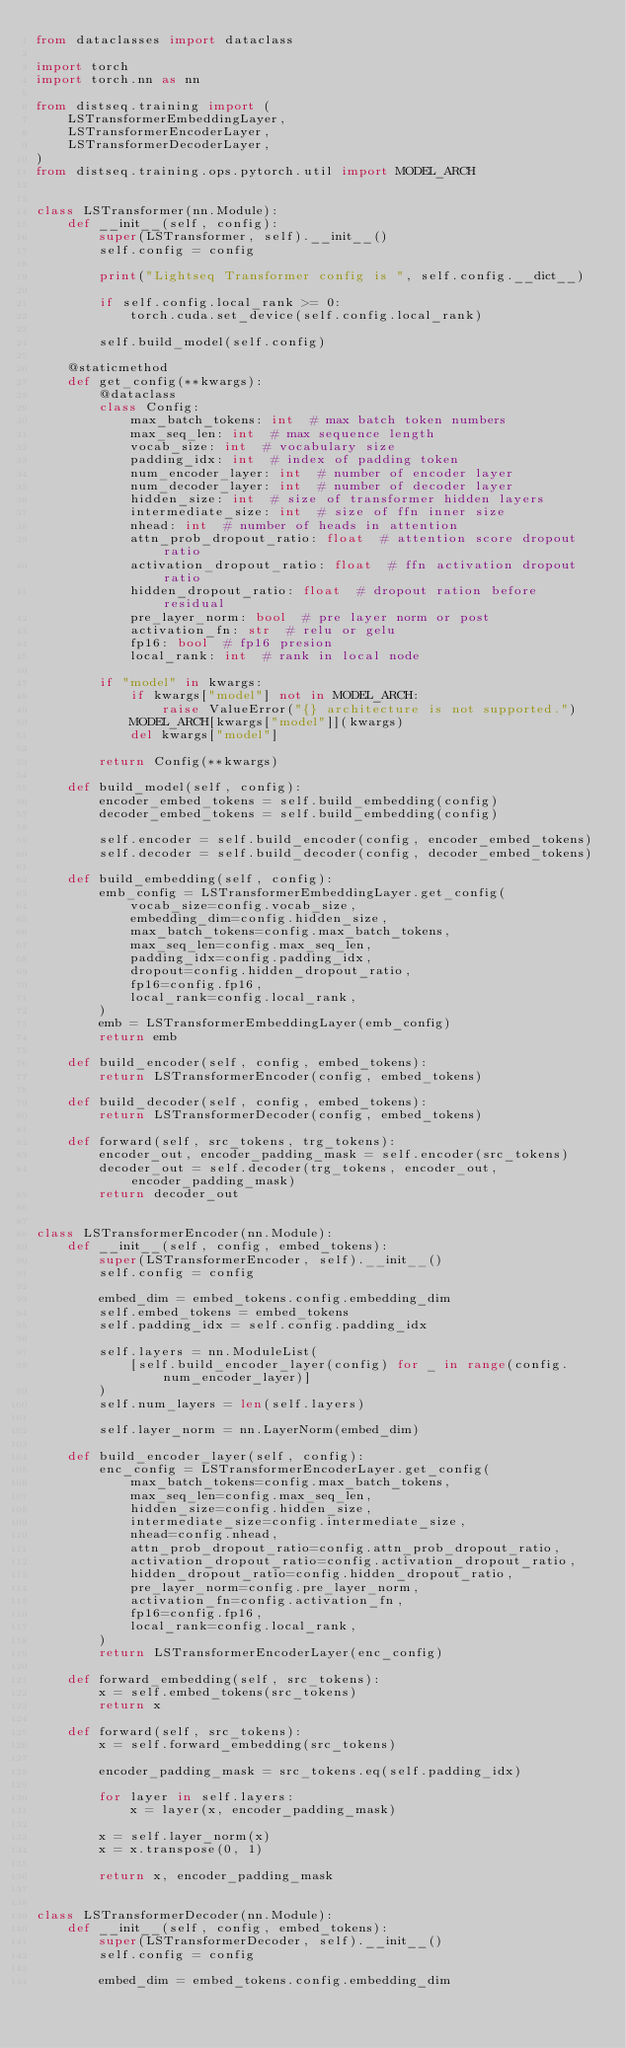<code> <loc_0><loc_0><loc_500><loc_500><_Python_>from dataclasses import dataclass

import torch
import torch.nn as nn

from distseq.training import (
    LSTransformerEmbeddingLayer,
    LSTransformerEncoderLayer,
    LSTransformerDecoderLayer,
)
from distseq.training.ops.pytorch.util import MODEL_ARCH


class LSTransformer(nn.Module):
    def __init__(self, config):
        super(LSTransformer, self).__init__()
        self.config = config

        print("Lightseq Transformer config is ", self.config.__dict__)

        if self.config.local_rank >= 0:
            torch.cuda.set_device(self.config.local_rank)

        self.build_model(self.config)

    @staticmethod
    def get_config(**kwargs):
        @dataclass
        class Config:
            max_batch_tokens: int  # max batch token numbers
            max_seq_len: int  # max sequence length
            vocab_size: int  # vocabulary size
            padding_idx: int  # index of padding token
            num_encoder_layer: int  # number of encoder layer
            num_decoder_layer: int  # number of decoder layer
            hidden_size: int  # size of transformer hidden layers
            intermediate_size: int  # size of ffn inner size
            nhead: int  # number of heads in attention
            attn_prob_dropout_ratio: float  # attention score dropout ratio
            activation_dropout_ratio: float  # ffn activation dropout ratio
            hidden_dropout_ratio: float  # dropout ration before residual
            pre_layer_norm: bool  # pre layer norm or post
            activation_fn: str  # relu or gelu
            fp16: bool  # fp16 presion
            local_rank: int  # rank in local node

        if "model" in kwargs:
            if kwargs["model"] not in MODEL_ARCH:
                raise ValueError("{} architecture is not supported.")
            MODEL_ARCH[kwargs["model"]](kwargs)
            del kwargs["model"]

        return Config(**kwargs)

    def build_model(self, config):
        encoder_embed_tokens = self.build_embedding(config)
        decoder_embed_tokens = self.build_embedding(config)

        self.encoder = self.build_encoder(config, encoder_embed_tokens)
        self.decoder = self.build_decoder(config, decoder_embed_tokens)

    def build_embedding(self, config):
        emb_config = LSTransformerEmbeddingLayer.get_config(
            vocab_size=config.vocab_size,
            embedding_dim=config.hidden_size,
            max_batch_tokens=config.max_batch_tokens,
            max_seq_len=config.max_seq_len,
            padding_idx=config.padding_idx,
            dropout=config.hidden_dropout_ratio,
            fp16=config.fp16,
            local_rank=config.local_rank,
        )
        emb = LSTransformerEmbeddingLayer(emb_config)
        return emb

    def build_encoder(self, config, embed_tokens):
        return LSTransformerEncoder(config, embed_tokens)

    def build_decoder(self, config, embed_tokens):
        return LSTransformerDecoder(config, embed_tokens)

    def forward(self, src_tokens, trg_tokens):
        encoder_out, encoder_padding_mask = self.encoder(src_tokens)
        decoder_out = self.decoder(trg_tokens, encoder_out, encoder_padding_mask)
        return decoder_out


class LSTransformerEncoder(nn.Module):
    def __init__(self, config, embed_tokens):
        super(LSTransformerEncoder, self).__init__()
        self.config = config

        embed_dim = embed_tokens.config.embedding_dim
        self.embed_tokens = embed_tokens
        self.padding_idx = self.config.padding_idx

        self.layers = nn.ModuleList(
            [self.build_encoder_layer(config) for _ in range(config.num_encoder_layer)]
        )
        self.num_layers = len(self.layers)

        self.layer_norm = nn.LayerNorm(embed_dim)

    def build_encoder_layer(self, config):
        enc_config = LSTransformerEncoderLayer.get_config(
            max_batch_tokens=config.max_batch_tokens,
            max_seq_len=config.max_seq_len,
            hidden_size=config.hidden_size,
            intermediate_size=config.intermediate_size,
            nhead=config.nhead,
            attn_prob_dropout_ratio=config.attn_prob_dropout_ratio,
            activation_dropout_ratio=config.activation_dropout_ratio,
            hidden_dropout_ratio=config.hidden_dropout_ratio,
            pre_layer_norm=config.pre_layer_norm,
            activation_fn=config.activation_fn,
            fp16=config.fp16,
            local_rank=config.local_rank,
        )
        return LSTransformerEncoderLayer(enc_config)

    def forward_embedding(self, src_tokens):
        x = self.embed_tokens(src_tokens)
        return x

    def forward(self, src_tokens):
        x = self.forward_embedding(src_tokens)

        encoder_padding_mask = src_tokens.eq(self.padding_idx)

        for layer in self.layers:
            x = layer(x, encoder_padding_mask)

        x = self.layer_norm(x)
        x = x.transpose(0, 1)

        return x, encoder_padding_mask


class LSTransformerDecoder(nn.Module):
    def __init__(self, config, embed_tokens):
        super(LSTransformerDecoder, self).__init__()
        self.config = config

        embed_dim = embed_tokens.config.embedding_dim</code> 